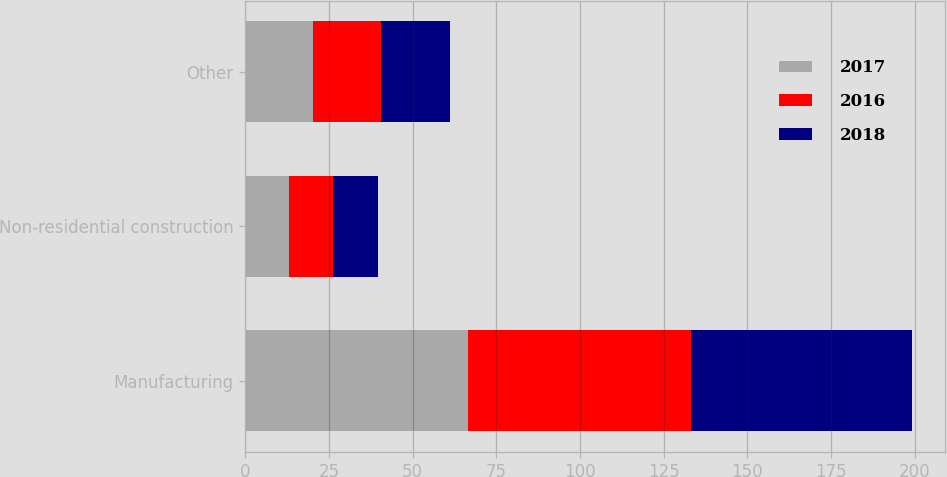<chart> <loc_0><loc_0><loc_500><loc_500><stacked_bar_chart><ecel><fcel>Manufacturing<fcel>Non-residential construction<fcel>Other<nl><fcel>2017<fcel>66.7<fcel>13.1<fcel>20.2<nl><fcel>2016<fcel>66.5<fcel>13<fcel>20.5<nl><fcel>2018<fcel>65.9<fcel>13.6<fcel>20.5<nl></chart> 